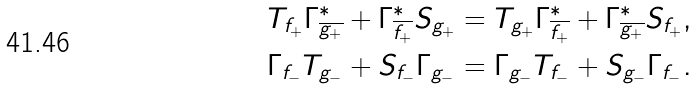Convert formula to latex. <formula><loc_0><loc_0><loc_500><loc_500>T _ { f _ { + } } { \Gamma ^ { * } _ { \overline { g _ { + } } } } + { \Gamma ^ { * } _ { \overline { f _ { + } } } } { S _ { g _ { + } } } & = T _ { g _ { + } } { \Gamma ^ { * } _ { \overline { f _ { + } } } } + { \Gamma ^ { * } _ { \overline { g _ { + } } } } { S _ { f _ { + } } } , \\ \Gamma _ { f _ { - } } T _ { g _ { - } } + S _ { f _ { - } } { \Gamma _ { g _ { - } } } & = \Gamma _ { g _ { - } } T _ { f _ { - } } + S _ { g _ { - } } { \Gamma _ { f _ { - } } } .</formula> 